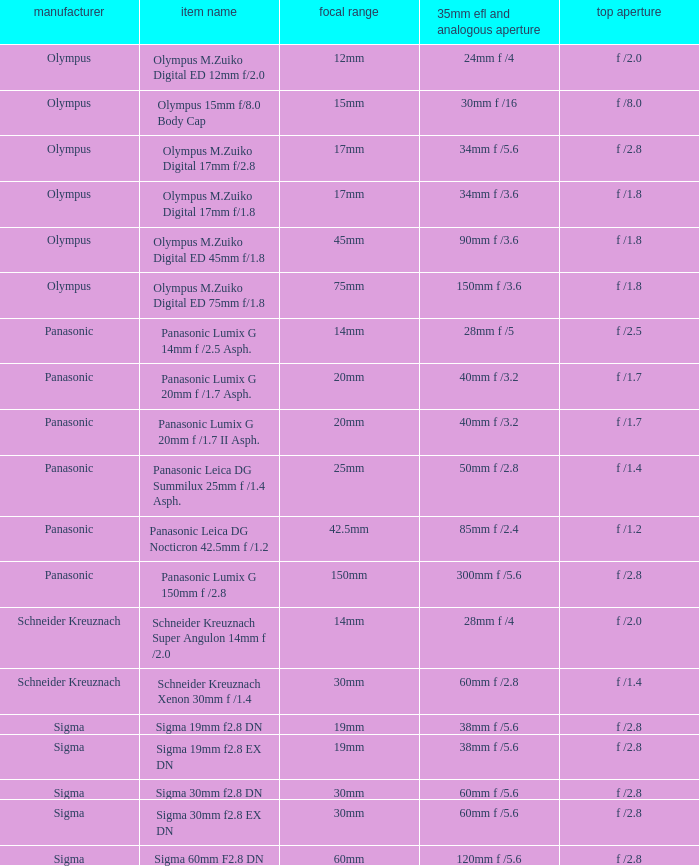What is the brand of the Sigma 30mm f2.8 DN, which has a maximum aperture of f /2.8 and a focal length of 30mm? Sigma. 